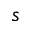<formula> <loc_0><loc_0><loc_500><loc_500>s</formula> 